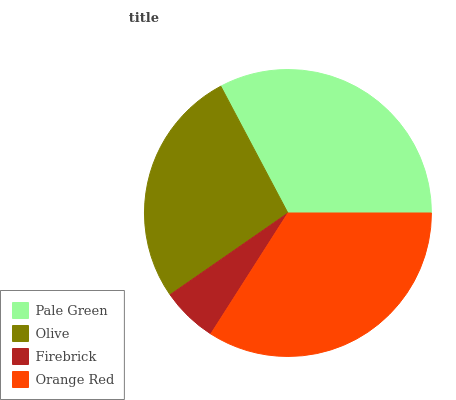Is Firebrick the minimum?
Answer yes or no. Yes. Is Orange Red the maximum?
Answer yes or no. Yes. Is Olive the minimum?
Answer yes or no. No. Is Olive the maximum?
Answer yes or no. No. Is Pale Green greater than Olive?
Answer yes or no. Yes. Is Olive less than Pale Green?
Answer yes or no. Yes. Is Olive greater than Pale Green?
Answer yes or no. No. Is Pale Green less than Olive?
Answer yes or no. No. Is Pale Green the high median?
Answer yes or no. Yes. Is Olive the low median?
Answer yes or no. Yes. Is Orange Red the high median?
Answer yes or no. No. Is Firebrick the low median?
Answer yes or no. No. 